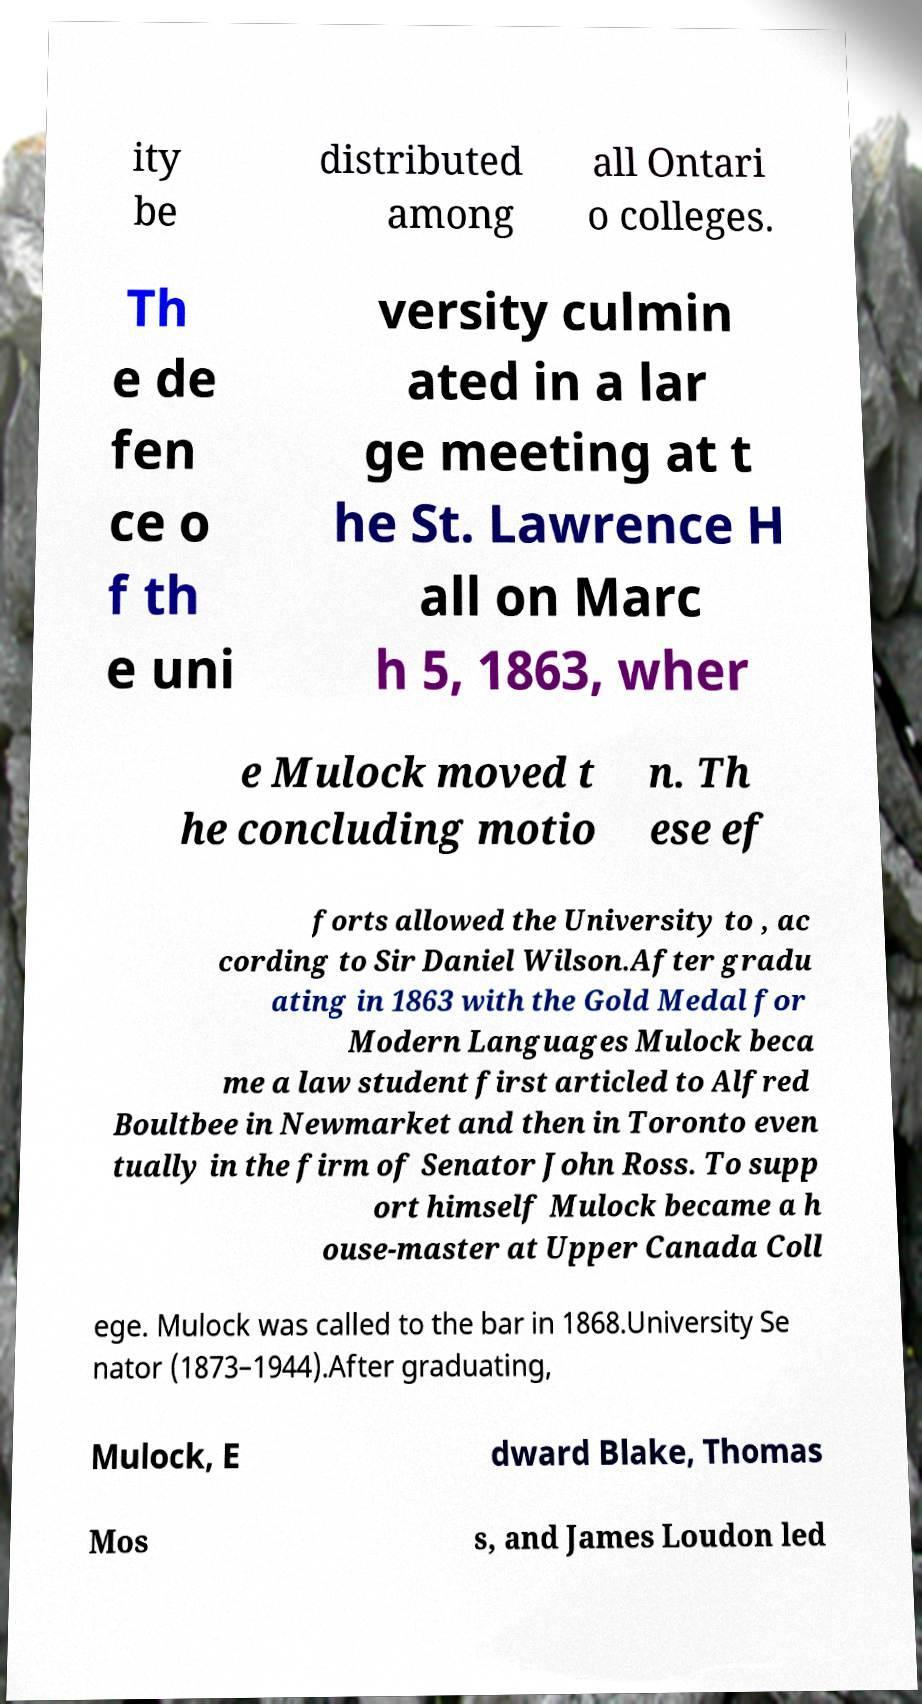There's text embedded in this image that I need extracted. Can you transcribe it verbatim? ity be distributed among all Ontari o colleges. Th e de fen ce o f th e uni versity culmin ated in a lar ge meeting at t he St. Lawrence H all on Marc h 5, 1863, wher e Mulock moved t he concluding motio n. Th ese ef forts allowed the University to , ac cording to Sir Daniel Wilson.After gradu ating in 1863 with the Gold Medal for Modern Languages Mulock beca me a law student first articled to Alfred Boultbee in Newmarket and then in Toronto even tually in the firm of Senator John Ross. To supp ort himself Mulock became a h ouse-master at Upper Canada Coll ege. Mulock was called to the bar in 1868.University Se nator (1873–1944).After graduating, Mulock, E dward Blake, Thomas Mos s, and James Loudon led 